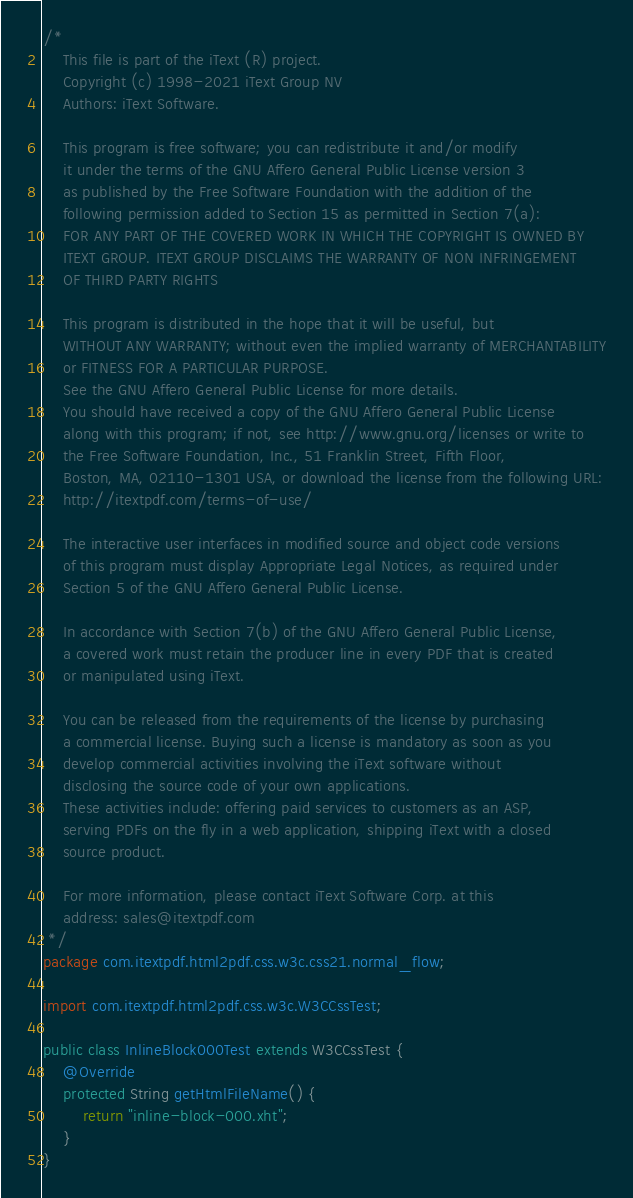Convert code to text. <code><loc_0><loc_0><loc_500><loc_500><_Java_>/*
    This file is part of the iText (R) project.
    Copyright (c) 1998-2021 iText Group NV
    Authors: iText Software.

    This program is free software; you can redistribute it and/or modify
    it under the terms of the GNU Affero General Public License version 3
    as published by the Free Software Foundation with the addition of the
    following permission added to Section 15 as permitted in Section 7(a):
    FOR ANY PART OF THE COVERED WORK IN WHICH THE COPYRIGHT IS OWNED BY
    ITEXT GROUP. ITEXT GROUP DISCLAIMS THE WARRANTY OF NON INFRINGEMENT
    OF THIRD PARTY RIGHTS

    This program is distributed in the hope that it will be useful, but
    WITHOUT ANY WARRANTY; without even the implied warranty of MERCHANTABILITY
    or FITNESS FOR A PARTICULAR PURPOSE.
    See the GNU Affero General Public License for more details.
    You should have received a copy of the GNU Affero General Public License
    along with this program; if not, see http://www.gnu.org/licenses or write to
    the Free Software Foundation, Inc., 51 Franklin Street, Fifth Floor,
    Boston, MA, 02110-1301 USA, or download the license from the following URL:
    http://itextpdf.com/terms-of-use/

    The interactive user interfaces in modified source and object code versions
    of this program must display Appropriate Legal Notices, as required under
    Section 5 of the GNU Affero General Public License.

    In accordance with Section 7(b) of the GNU Affero General Public License,
    a covered work must retain the producer line in every PDF that is created
    or manipulated using iText.

    You can be released from the requirements of the license by purchasing
    a commercial license. Buying such a license is mandatory as soon as you
    develop commercial activities involving the iText software without
    disclosing the source code of your own applications.
    These activities include: offering paid services to customers as an ASP,
    serving PDFs on the fly in a web application, shipping iText with a closed
    source product.

    For more information, please contact iText Software Corp. at this
    address: sales@itextpdf.com
 */
package com.itextpdf.html2pdf.css.w3c.css21.normal_flow;

import com.itextpdf.html2pdf.css.w3c.W3CCssTest;

public class InlineBlock000Test extends W3CCssTest {
    @Override
    protected String getHtmlFileName() {
        return "inline-block-000.xht";
    }
}
</code> 